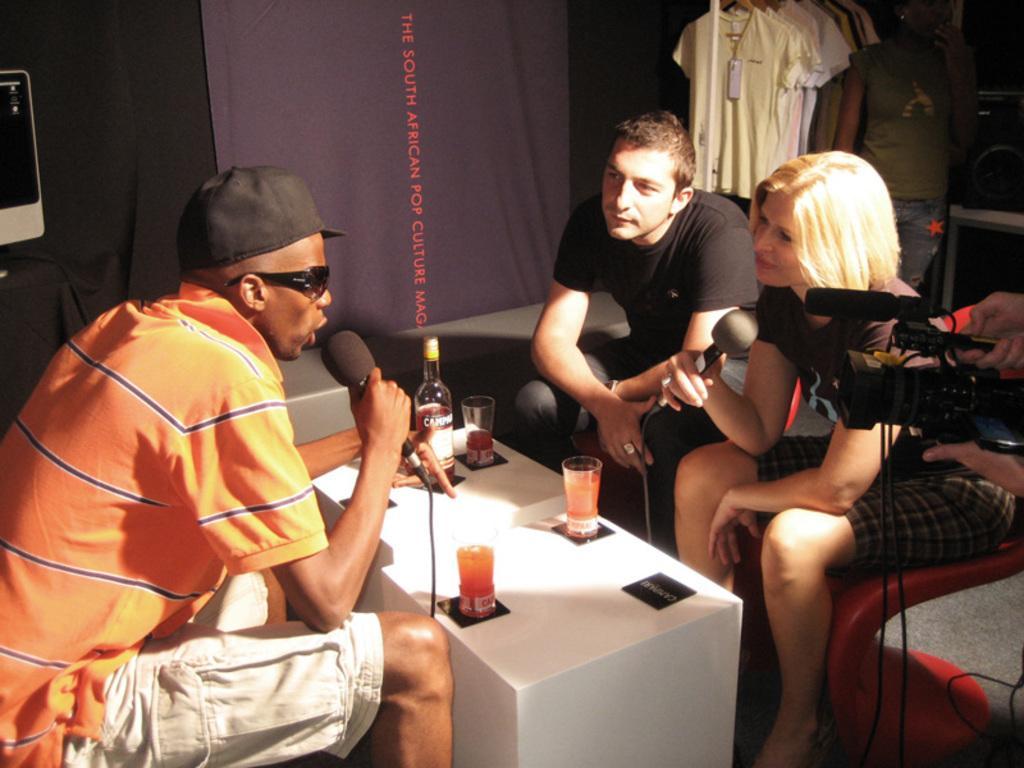How would you summarize this image in a sentence or two? The picture is taken inside a room. In the left hand side we can see a man wearing orange t shirt and white shorts is holding one mic and talking something. He is wearing a black cap and sunglasses also. It is looking like he is talking to the persons in front of him. In front of him a man and woman sitting on a sofa. The woman is holding one mic. In the middle there is table on the table there is bottle and three glasses. In the right hand side a man holding a camera. the camera is panned on the man on the left. In the background we can see a man is standing. Beside the person there is one rack on which t shirts are hanged. The background black and purple curtains. 